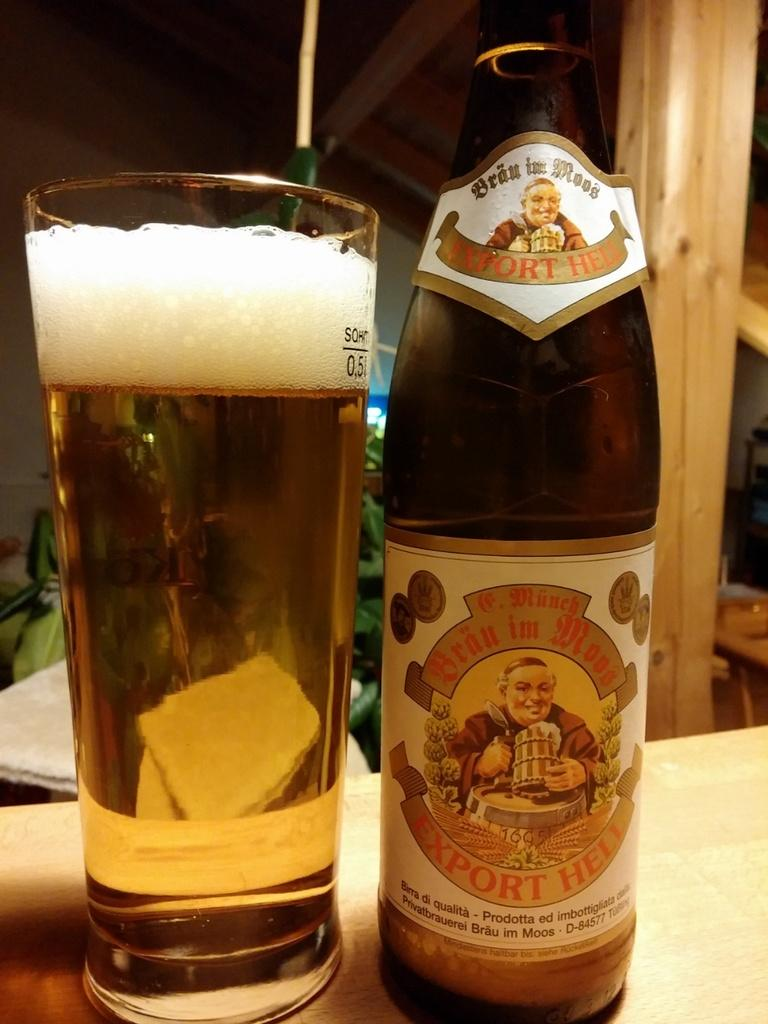<image>
Describe the image concisely. A bottle of beer has the identifying number D-84577 on the bottom part of its label. 